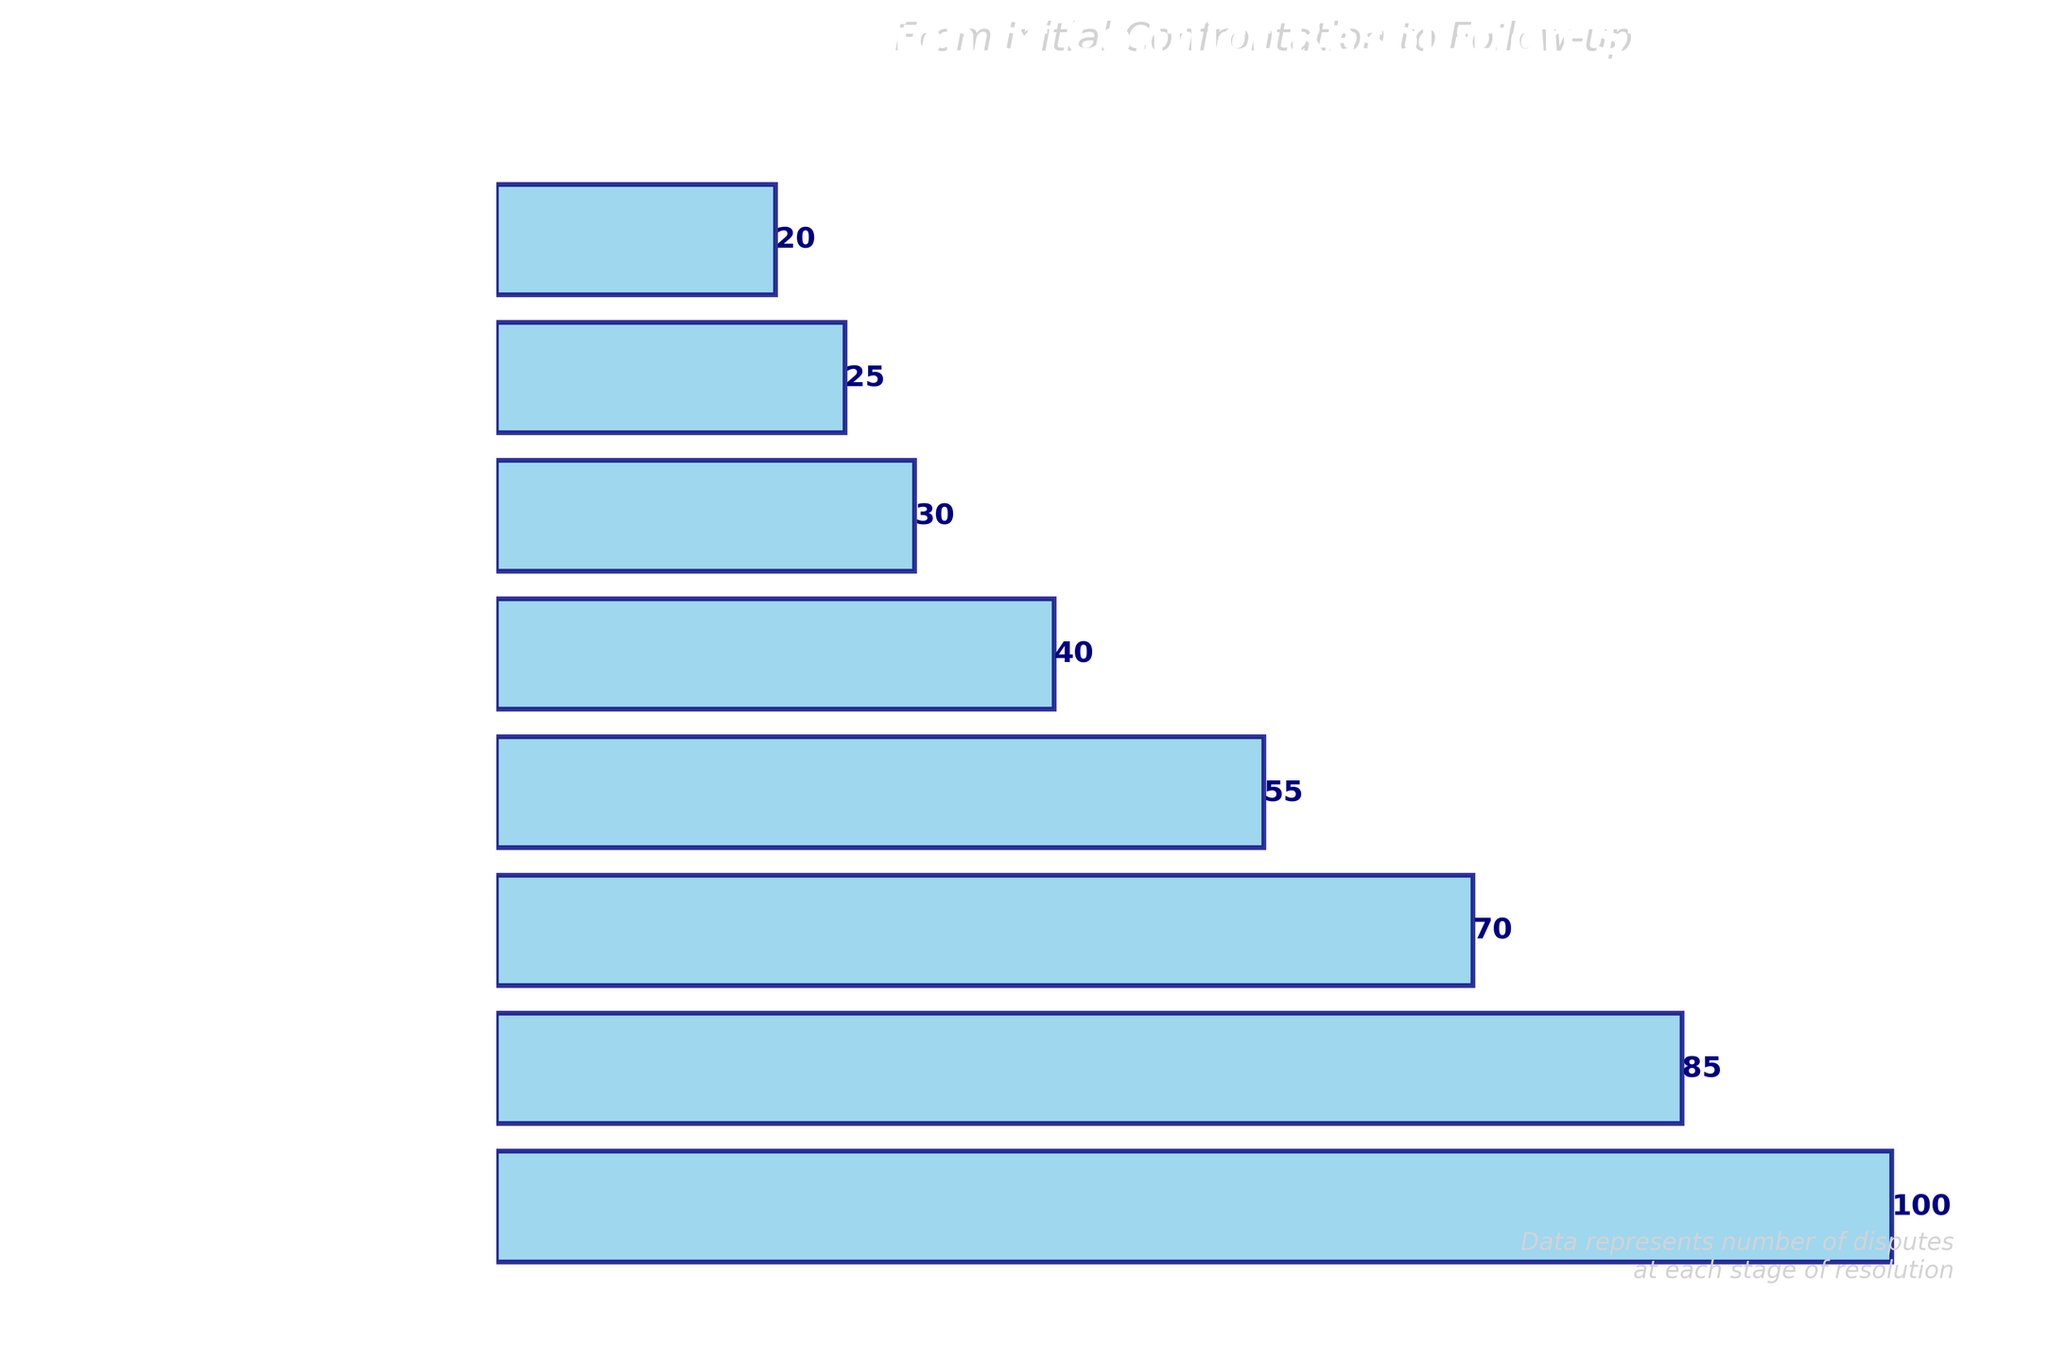What is the title of the funnel chart? The title of the funnel chart is displayed at the top of the figure. It reads "Progression of Conflict Resolution Strategies" in bold font.
Answer: Progression of Conflict Resolution Strategies How many stages are represented in the funnel chart? Count the number of distinct stages listed in the y-axis of the funnel chart. There are eight stages listed.
Answer: 8 Which stage has the highest number of disputes? Look at the stage with the longest bar, which is at the top since the funnel chart decreases in width as it goes down. The "Initial Confrontation" stage has the highest number of disputes.
Answer: Initial Confrontation By how much does the number of disputes decrease from "Active Listening" to "Brainstorming Solutions"? Subtract the number of disputes in the "Brainstorming Solutions" stage from the number in the "Active Listening" stage (85 - 55).
Answer: 30 What stage follows after "Brainstorming Solutions"? Refer to the order of the stages listed; the stage immediately below "Brainstorming Solutions" is "Negotiation".
Answer: Negotiation What is the total number of disputes resolved by the end of the last stage? The last stage is "Follow-up and Evaluation." This stage has 20 disputes, which indicates the total number of disputes resolved by the end.
Answer: 20 What percentage of the initial disputes reached the "Agreement" stage? Divide the number of disputes in the "Agreement" stage (30) by the initial number of disputes (100) and multiply by 100 to get the percentage: (30/100) × 100 = 30%.
Answer: 30% Which stage has a decrease of 45 disputes when compared with its preceding stage? Calculate the difference in disputes between each consecutive pair of stages. The difference between "Identifying Core Issues" (70 disputes) and "Brainstorming Solutions" (55 disputes) is 70 - 55 = 15. Therefore, no stage has a 45-dispute decrease. The closest significant decrease is between "Active Listening" (85) and "Brainstorming Solutions" (55), which is 30.
Answer: None Is the number of disputes in the "Implementation" stage greater than half of the disputes in the "Initial Confrontation" stage? Compare the number of disputes in "Implementation" (25) with half of the disputes in "Initial Confrontation" (50). Yes, 25 is less than 50.
Answer: No What is the average number of disputes from the "Initial Confrontation" to "Follow-up and Evaluation" stages? Add the numbers of disputes across all stages and divide by the total number of stages: (100 + 85 + 70 + 55 + 40 + 30 + 25 + 20) / 8 = 425 / 8 = 53.125.
Answer: 53.125 